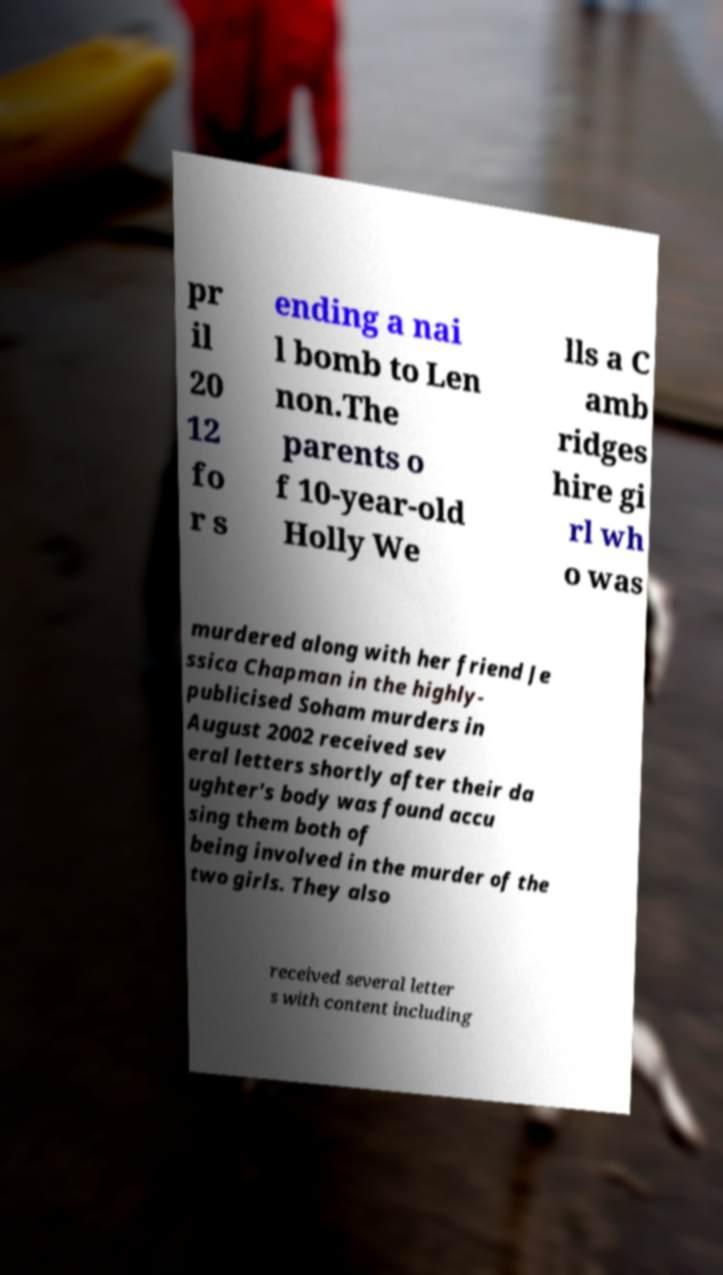Could you extract and type out the text from this image? pr il 20 12 fo r s ending a nai l bomb to Len non.The parents o f 10-year-old Holly We lls a C amb ridges hire gi rl wh o was murdered along with her friend Je ssica Chapman in the highly- publicised Soham murders in August 2002 received sev eral letters shortly after their da ughter's body was found accu sing them both of being involved in the murder of the two girls. They also received several letter s with content including 